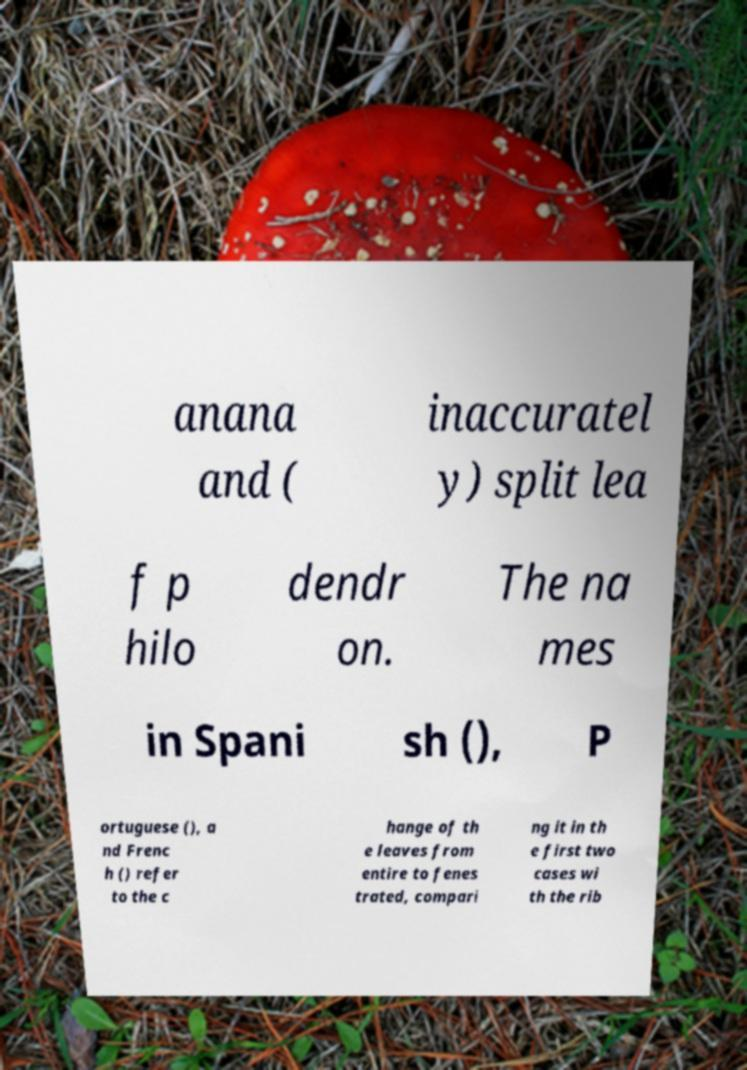Could you assist in decoding the text presented in this image and type it out clearly? anana and ( inaccuratel y) split lea f p hilo dendr on. The na mes in Spani sh (), P ortuguese (), a nd Frenc h () refer to the c hange of th e leaves from entire to fenes trated, compari ng it in th e first two cases wi th the rib 